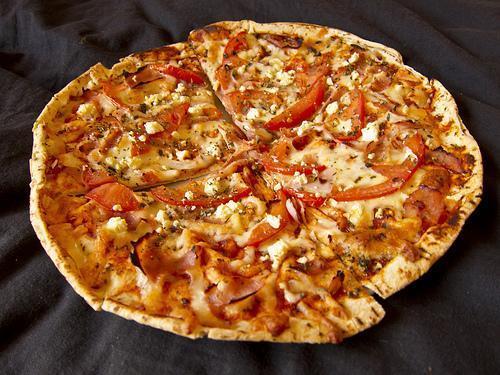How many pizzas are there?
Give a very brief answer. 1. 